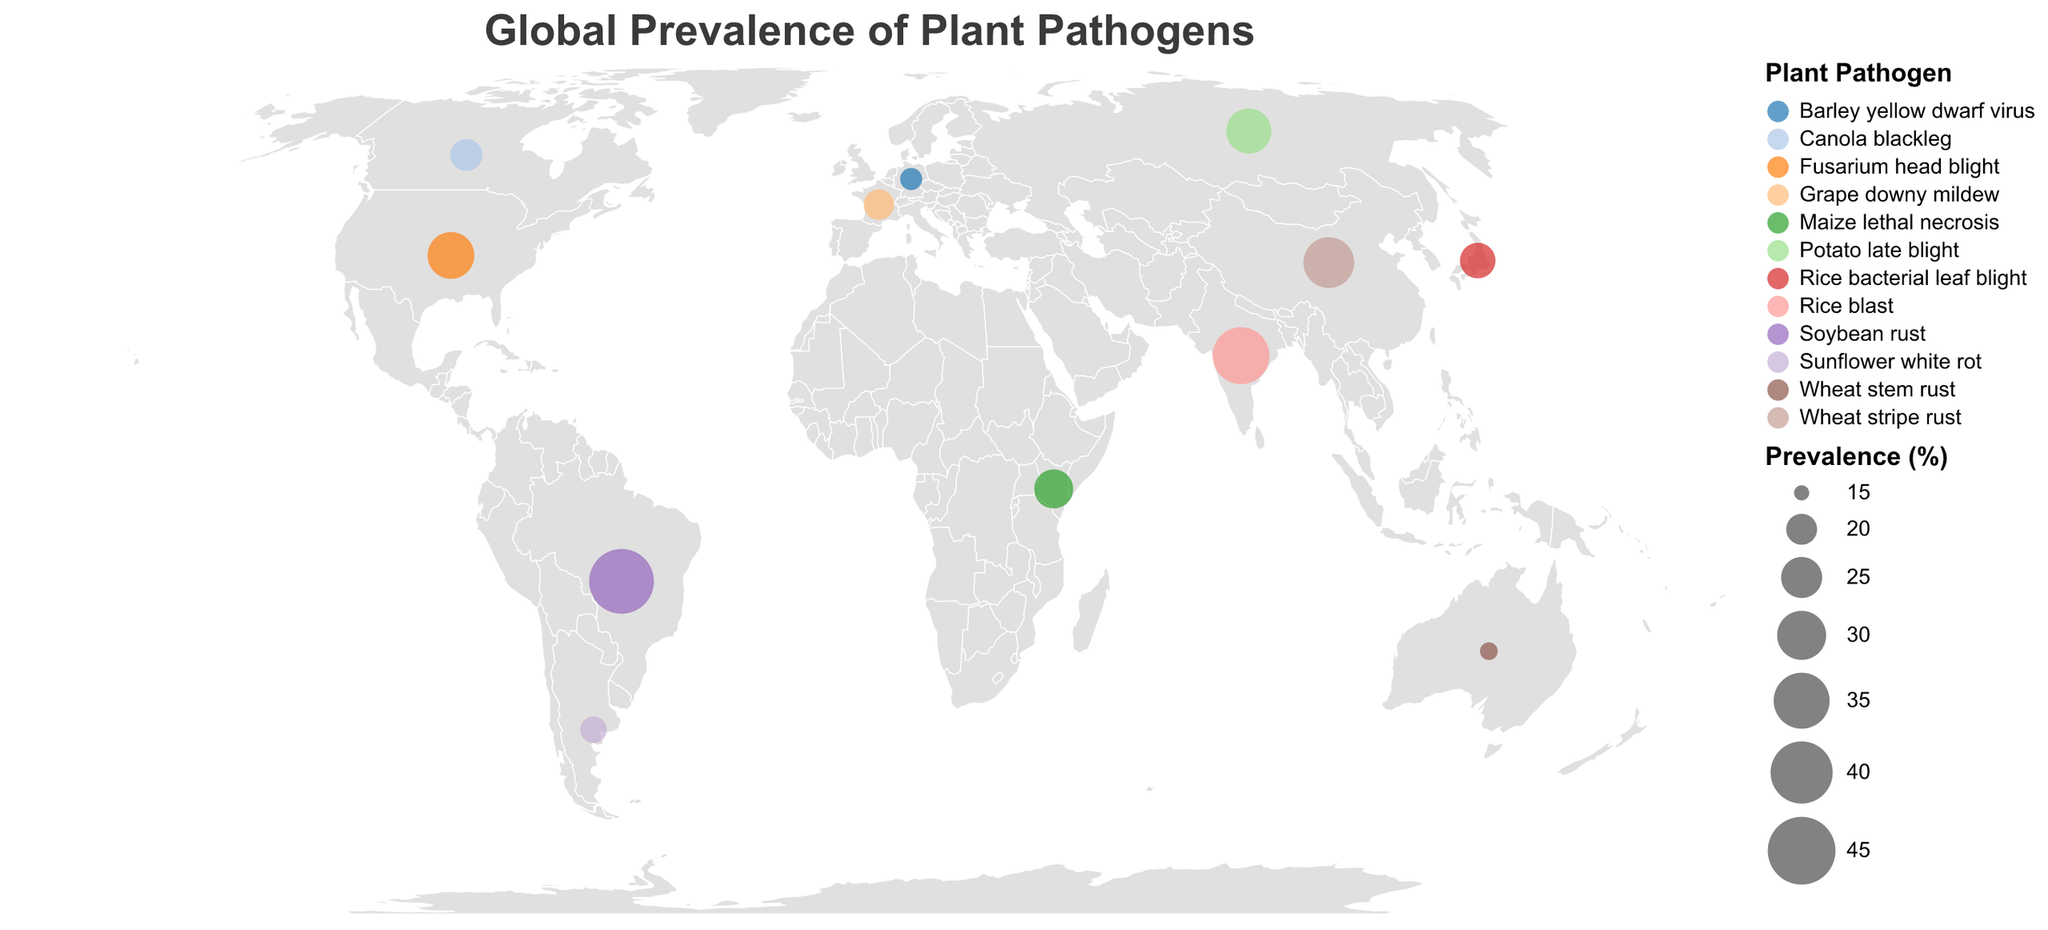What is the title of the figure? The title is typically the most prominent text at the top of the plot. In this case, it's "Global Prevalence of Plant Pathogens."
Answer: Global Prevalence of Plant Pathogens Which country has the highest prevalence percentage for a plant pathogen? By observing the size of the circles, the largest circle represents the highest prevalence. Brazil's data point shows the highest prevalence percentage at 42.3%.
Answer: Brazil Which countries have a prevalence percentage below 20%? By examining the sizes of the circles, the smaller ones correlate with lower prevalence percentages. France (19.8%), Australia (15.6%), and Argentina (18.3%) all have prevalence percentages below 20%.
Answer: France, Australia, Argentina What plant pathogen is prevalent in Japan, and what is its prevalence percentage? Hovering over or clicking on Japan's data point will show the tooltip with details: The prevalent pathogen is "Rice bacterial leaf blight" with a prevalence percentage of 22.1%.
Answer: Rice bacterial leaf blight, 22.1% Compare the prevalence percentage of Rice blast in India and Rice bacterial leaf blight in Japan. Which is higher? Referring to the data or tooltips, India (Rice blast - 35.7%) has a higher prevalence percentage than Japan (Rice bacterial leaf blight - 22.1%).
Answer: India Which pathogen is prevalent in Australia, and is its prevalence above or below 20%? By checking the tooltip or circle size for Australia, we see the pathogen is "Wheat stem rust" with a prevalence of 15.6%, which is below 20%.
Answer: Wheat stem rust, below 20% What is the average prevalence percentage of the pathogens in North American countries (United States and Canada)? The prevalence percentages for the United States (28.5%) and Canada (20.5%) need to be averaged: (28.5 + 20.5) / 2 = 24.5%.
Answer: 24.5% What plant pathogen is prevalent in Kenya, and how does its prevalence compare to that in Russia? The pathogen in Kenya is "Maize lethal necrosis" (23.9%), and in Russia, it is "Potato late blight" (27.4%). Potato late blight in Russia has a higher prevalence.
Answer: Maize lethal necrosis, Russia has higher Identify the pathogen with the highest prevalence and the country it affects. The largest circle will indicate the highest prevalence. "Soybean rust" in Brazil has the highest prevalence percentage, 42.3%.
Answer: Soybean rust, Brazil How many different plant pathogens are shown in this figure? By counting the unique entries in the legend or circle tooltips, there are 12 distinct plant pathogens displayed in the figure.
Answer: 12 